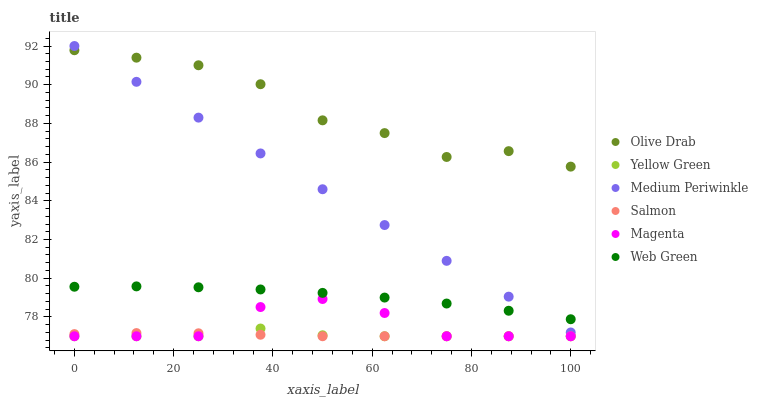Does Yellow Green have the minimum area under the curve?
Answer yes or no. Yes. Does Olive Drab have the maximum area under the curve?
Answer yes or no. Yes. Does Medium Periwinkle have the minimum area under the curve?
Answer yes or no. No. Does Medium Periwinkle have the maximum area under the curve?
Answer yes or no. No. Is Medium Periwinkle the smoothest?
Answer yes or no. Yes. Is Olive Drab the roughest?
Answer yes or no. Yes. Is Salmon the smoothest?
Answer yes or no. No. Is Salmon the roughest?
Answer yes or no. No. Does Yellow Green have the lowest value?
Answer yes or no. Yes. Does Medium Periwinkle have the lowest value?
Answer yes or no. No. Does Medium Periwinkle have the highest value?
Answer yes or no. Yes. Does Salmon have the highest value?
Answer yes or no. No. Is Web Green less than Olive Drab?
Answer yes or no. Yes. Is Olive Drab greater than Salmon?
Answer yes or no. Yes. Does Medium Periwinkle intersect Olive Drab?
Answer yes or no. Yes. Is Medium Periwinkle less than Olive Drab?
Answer yes or no. No. Is Medium Periwinkle greater than Olive Drab?
Answer yes or no. No. Does Web Green intersect Olive Drab?
Answer yes or no. No. 